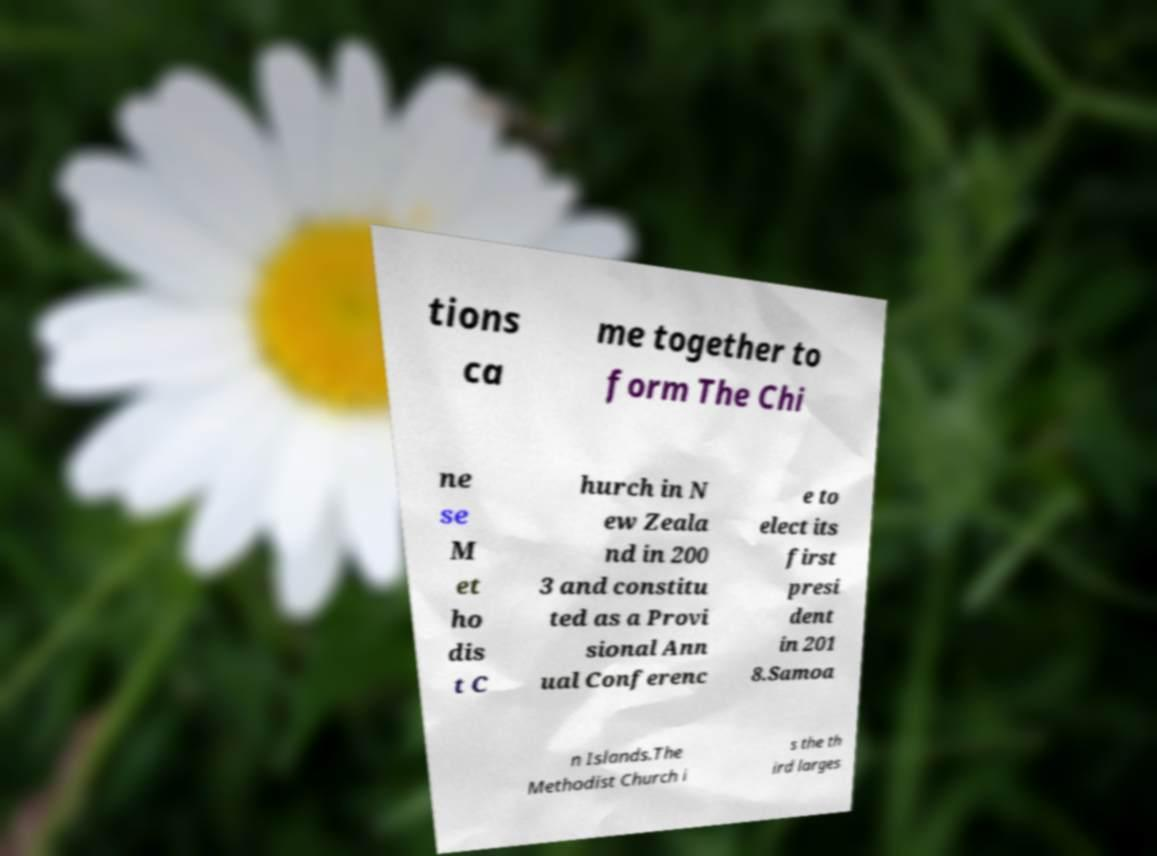I need the written content from this picture converted into text. Can you do that? tions ca me together to form The Chi ne se M et ho dis t C hurch in N ew Zeala nd in 200 3 and constitu ted as a Provi sional Ann ual Conferenc e to elect its first presi dent in 201 8.Samoa n Islands.The Methodist Church i s the th ird larges 